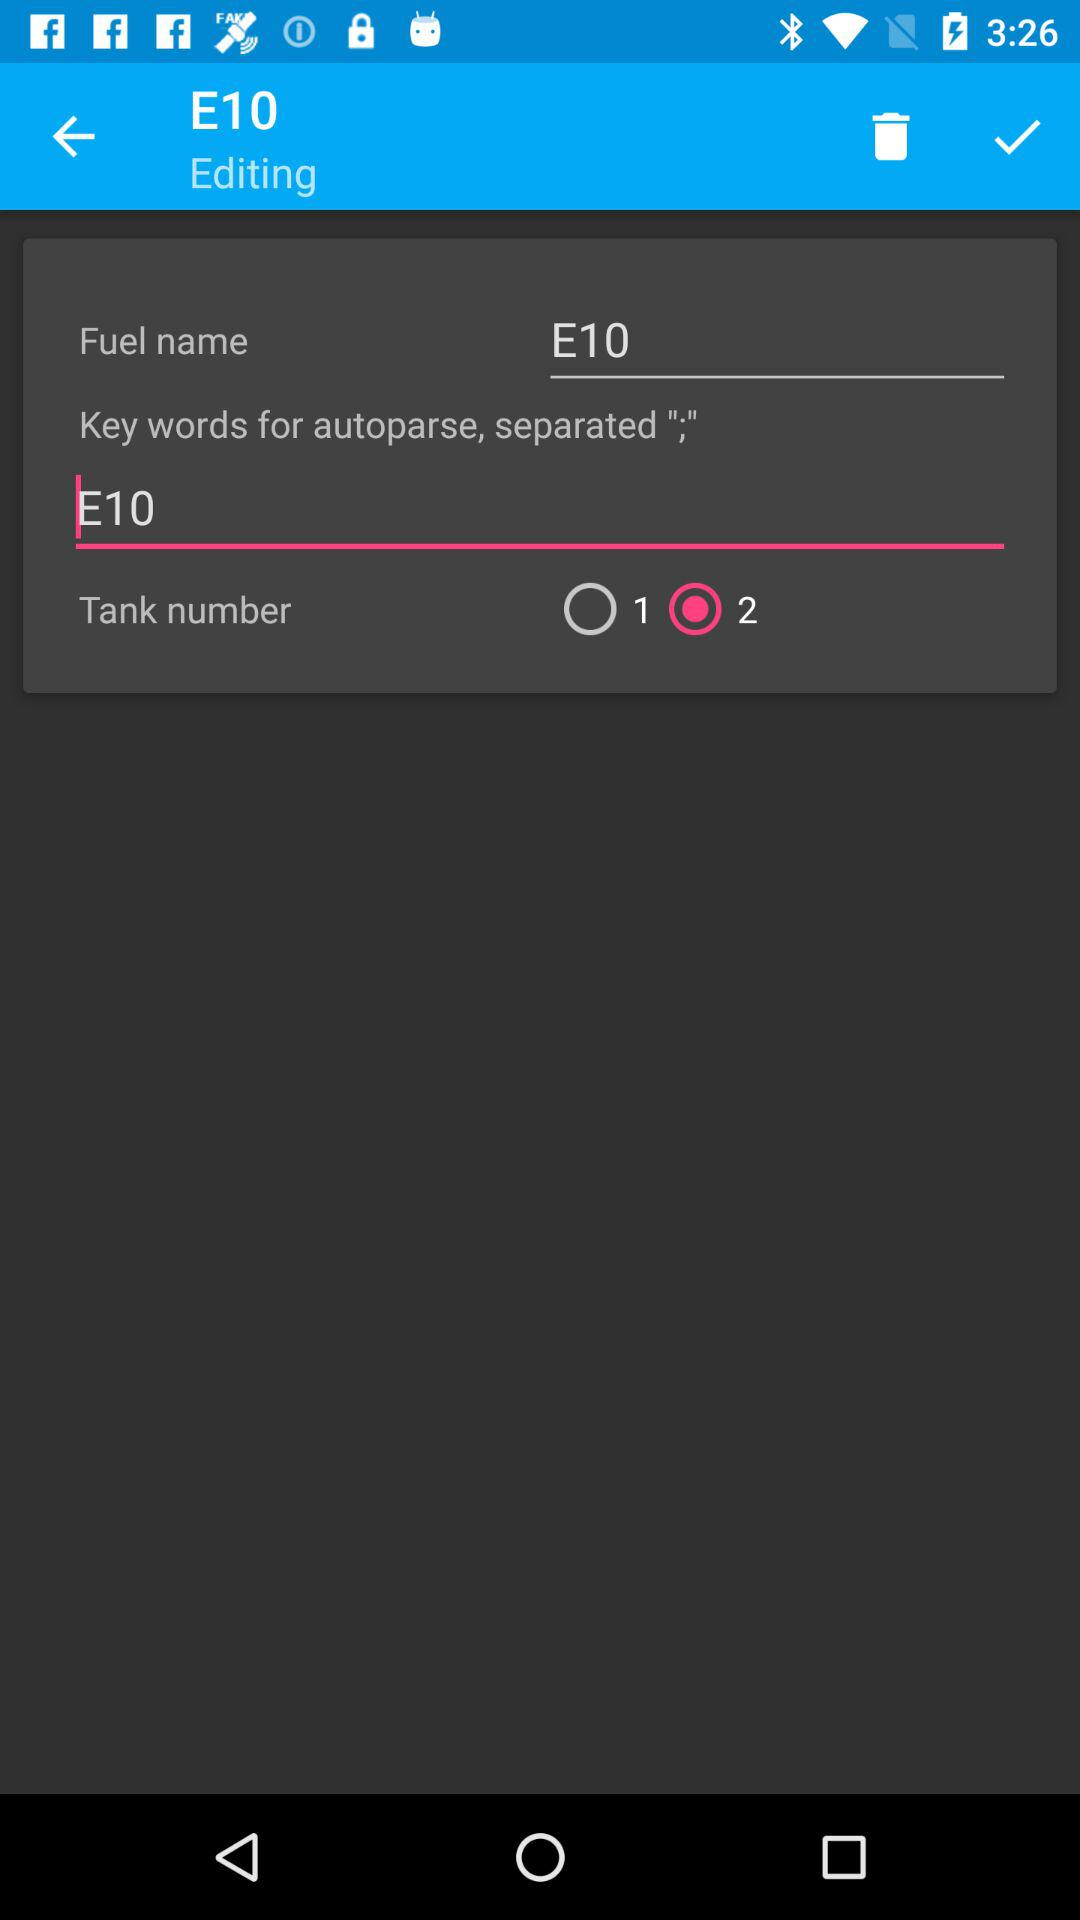What is the status of 1? The status is off. 